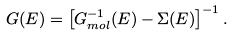<formula> <loc_0><loc_0><loc_500><loc_500>G ( E ) = \left [ G _ { m o l } ^ { - 1 } ( E ) - \Sigma ( E ) \right ] ^ { - 1 } .</formula> 